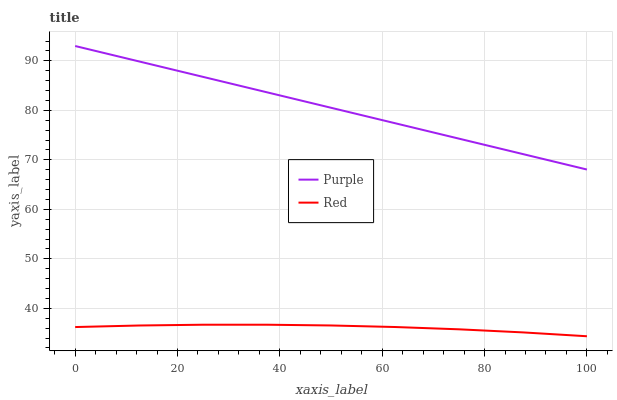Does Red have the minimum area under the curve?
Answer yes or no. Yes. Does Purple have the maximum area under the curve?
Answer yes or no. Yes. Does Red have the maximum area under the curve?
Answer yes or no. No. Is Purple the smoothest?
Answer yes or no. Yes. Is Red the roughest?
Answer yes or no. Yes. Is Red the smoothest?
Answer yes or no. No. Does Red have the lowest value?
Answer yes or no. Yes. Does Purple have the highest value?
Answer yes or no. Yes. Does Red have the highest value?
Answer yes or no. No. Is Red less than Purple?
Answer yes or no. Yes. Is Purple greater than Red?
Answer yes or no. Yes. Does Red intersect Purple?
Answer yes or no. No. 